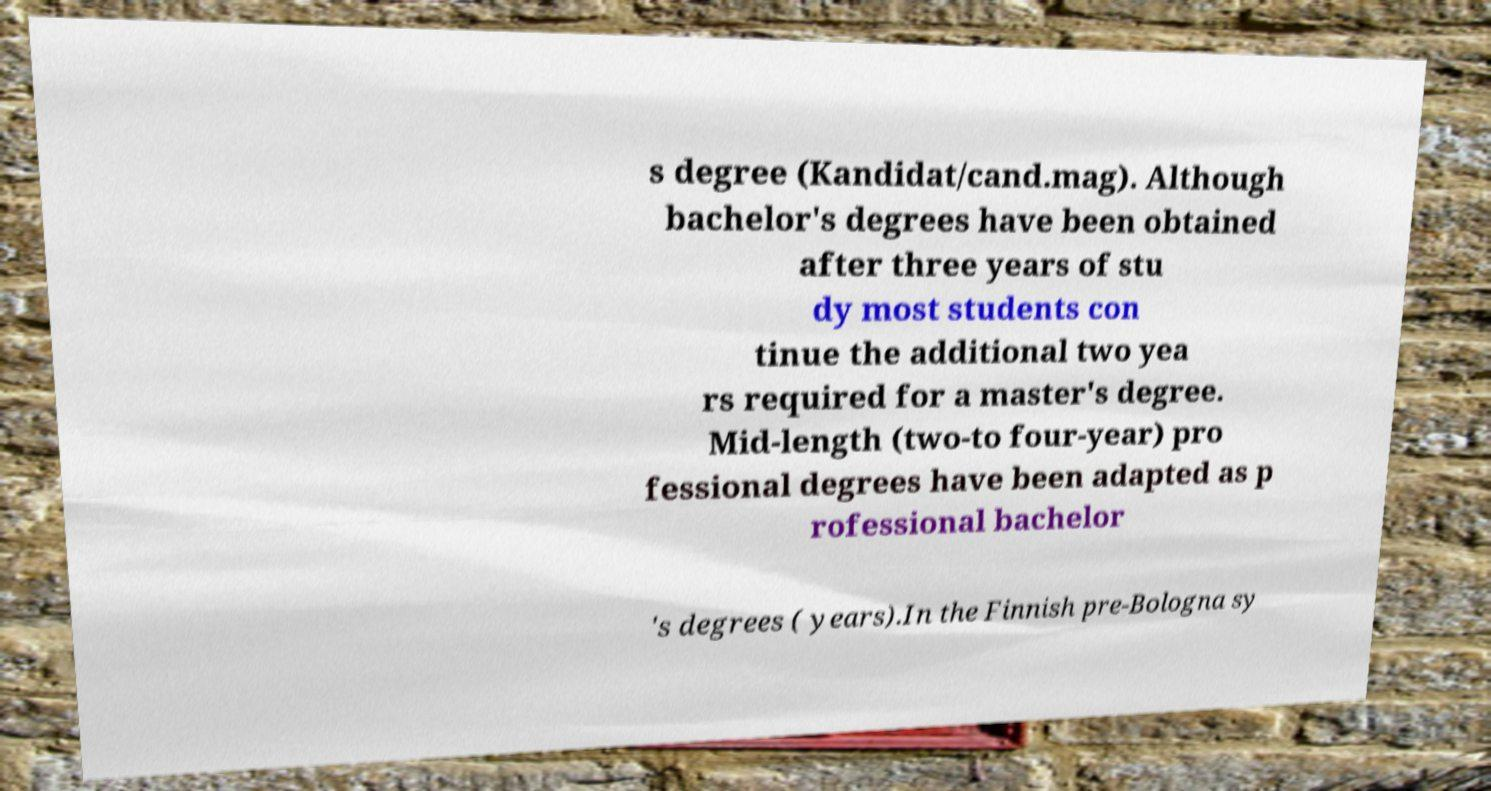For documentation purposes, I need the text within this image transcribed. Could you provide that? s degree (Kandidat/cand.mag). Although bachelor's degrees have been obtained after three years of stu dy most students con tinue the additional two yea rs required for a master's degree. Mid-length (two-to four-year) pro fessional degrees have been adapted as p rofessional bachelor 's degrees ( years).In the Finnish pre-Bologna sy 